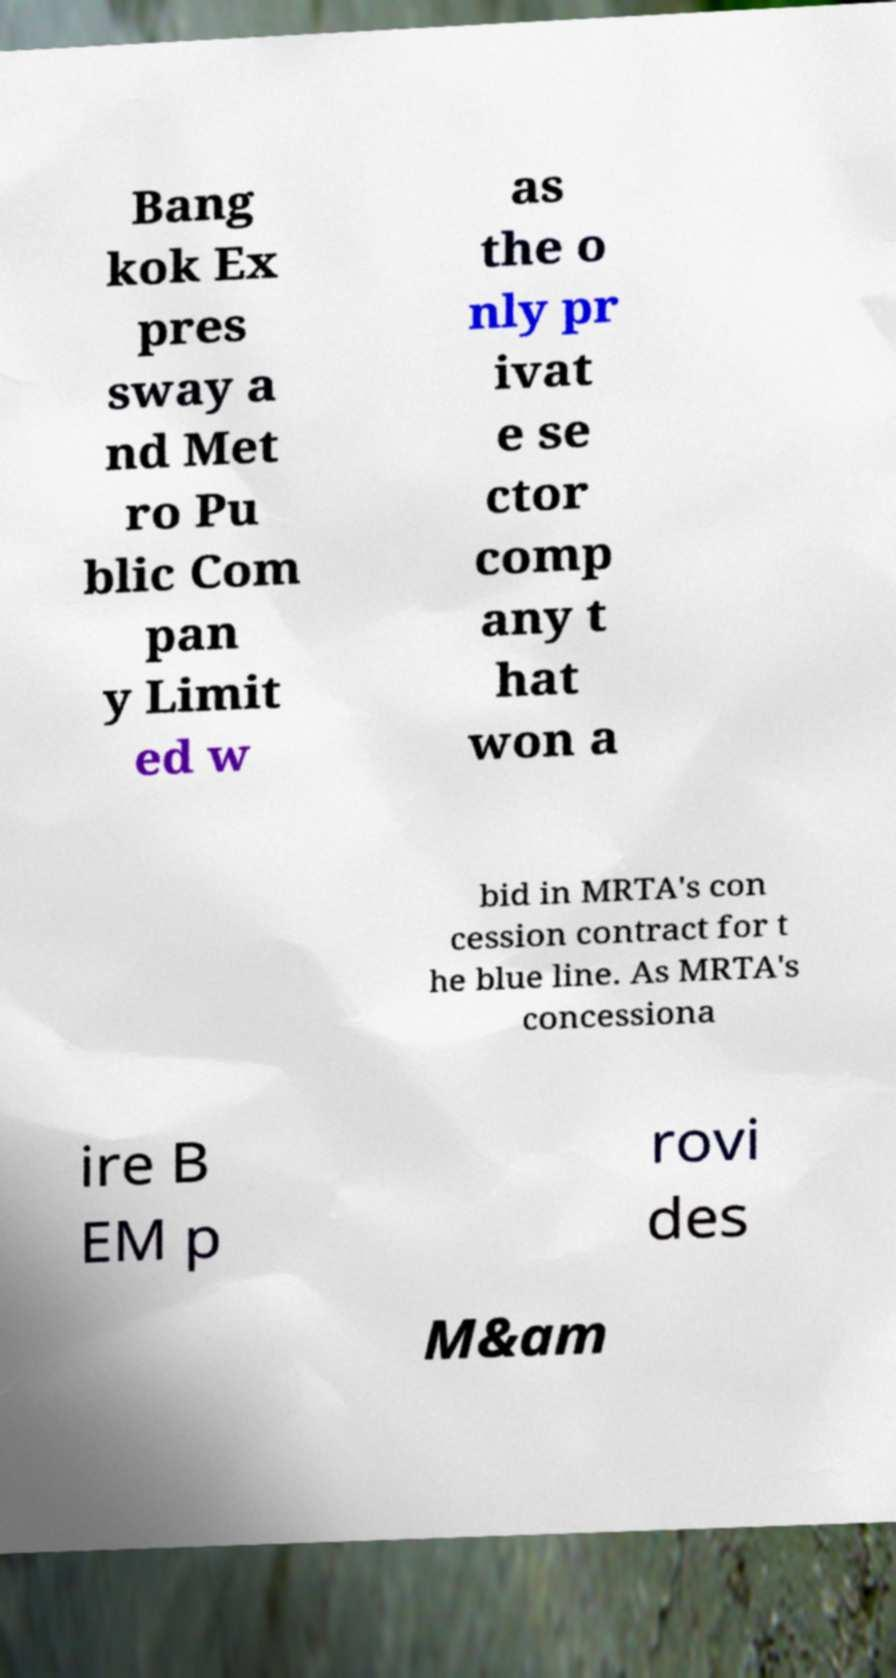I need the written content from this picture converted into text. Can you do that? Bang kok Ex pres sway a nd Met ro Pu blic Com pan y Limit ed w as the o nly pr ivat e se ctor comp any t hat won a bid in MRTA's con cession contract for t he blue line. As MRTA's concessiona ire B EM p rovi des M&am 